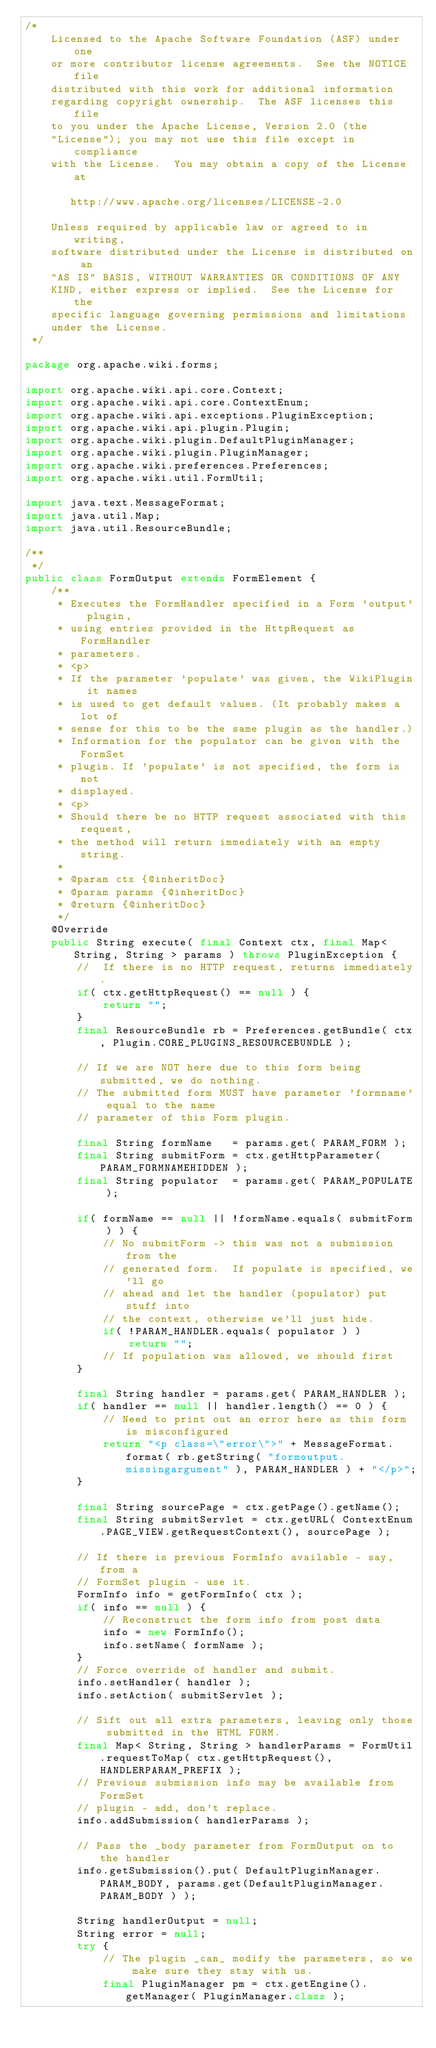<code> <loc_0><loc_0><loc_500><loc_500><_Java_>/* 
    Licensed to the Apache Software Foundation (ASF) under one
    or more contributor license agreements.  See the NOTICE file
    distributed with this work for additional information
    regarding copyright ownership.  The ASF licenses this file
    to you under the Apache License, Version 2.0 (the
    "License"); you may not use this file except in compliance
    with the License.  You may obtain a copy of the License at

       http://www.apache.org/licenses/LICENSE-2.0

    Unless required by applicable law or agreed to in writing,
    software distributed under the License is distributed on an
    "AS IS" BASIS, WITHOUT WARRANTIES OR CONDITIONS OF ANY
    KIND, either express or implied.  See the License for the
    specific language governing permissions and limitations
    under the License.  
 */

package org.apache.wiki.forms;

import org.apache.wiki.api.core.Context;
import org.apache.wiki.api.core.ContextEnum;
import org.apache.wiki.api.exceptions.PluginException;
import org.apache.wiki.api.plugin.Plugin;
import org.apache.wiki.plugin.DefaultPluginManager;
import org.apache.wiki.plugin.PluginManager;
import org.apache.wiki.preferences.Preferences;
import org.apache.wiki.util.FormUtil;

import java.text.MessageFormat;
import java.util.Map;
import java.util.ResourceBundle;

/**
 */
public class FormOutput extends FormElement {
    /**
     * Executes the FormHandler specified in a Form 'output' plugin,
     * using entries provided in the HttpRequest as FormHandler
     * parameters.
     * <p>
     * If the parameter 'populate' was given, the WikiPlugin it names
     * is used to get default values. (It probably makes a lot of
     * sense for this to be the same plugin as the handler.) 
     * Information for the populator can be given with the FormSet
     * plugin. If 'populate' is not specified, the form is not
     * displayed.
     * <p>
     * Should there be no HTTP request associated with this request,
     * the method will return immediately with an empty string.
     * 
     * @param ctx {@inheritDoc}
     * @param params {@inheritDoc}
     * @return {@inheritDoc}
     */
    @Override
    public String execute( final Context ctx, final Map< String, String > params ) throws PluginException {
        //  If there is no HTTP request, returns immediately.
        if( ctx.getHttpRequest() == null ) {
            return "";
        }
        final ResourceBundle rb = Preferences.getBundle( ctx, Plugin.CORE_PLUGINS_RESOURCEBUNDLE );
        
        // If we are NOT here due to this form being submitted, we do nothing.
        // The submitted form MUST have parameter 'formname' equal to the name
        // parameter of this Form plugin.

        final String formName   = params.get( PARAM_FORM );
        final String submitForm = ctx.getHttpParameter( PARAM_FORMNAMEHIDDEN );
        final String populator  = params.get( PARAM_POPULATE );

        if( formName == null || !formName.equals( submitForm ) ) {
            // No submitForm -> this was not a submission from the
            // generated form.  If populate is specified, we'll go
            // ahead and let the handler (populator) put stuff into
            // the context, otherwise we'll just hide.
            if( !PARAM_HANDLER.equals( populator ) )
                return "";
            // If population was allowed, we should first  
        }

        final String handler = params.get( PARAM_HANDLER );
        if( handler == null || handler.length() == 0 ) {
            // Need to print out an error here as this form is misconfigured
            return "<p class=\"error\">" + MessageFormat.format( rb.getString( "formoutput.missingargument" ), PARAM_HANDLER ) + "</p>";
        }

        final String sourcePage = ctx.getPage().getName();
        final String submitServlet = ctx.getURL( ContextEnum.PAGE_VIEW.getRequestContext(), sourcePage );

        // If there is previous FormInfo available - say, from a
        // FormSet plugin - use it.
        FormInfo info = getFormInfo( ctx );
        if( info == null ) {
            // Reconstruct the form info from post data
            info = new FormInfo();
            info.setName( formName );
        }
        // Force override of handler and submit.
        info.setHandler( handler );
        info.setAction( submitServlet );

        // Sift out all extra parameters, leaving only those submitted in the HTML FORM.
        final Map< String, String > handlerParams = FormUtil.requestToMap( ctx.getHttpRequest(), HANDLERPARAM_PREFIX );
        // Previous submission info may be available from FormSet
        // plugin - add, don't replace.
        info.addSubmission( handlerParams );

        // Pass the _body parameter from FormOutput on to the handler
        info.getSubmission().put( DefaultPluginManager.PARAM_BODY, params.get(DefaultPluginManager.PARAM_BODY ) );

        String handlerOutput = null;
        String error = null;
        try {
            // The plugin _can_ modify the parameters, so we make sure they stay with us.
            final PluginManager pm = ctx.getEngine().getManager( PluginManager.class );</code> 